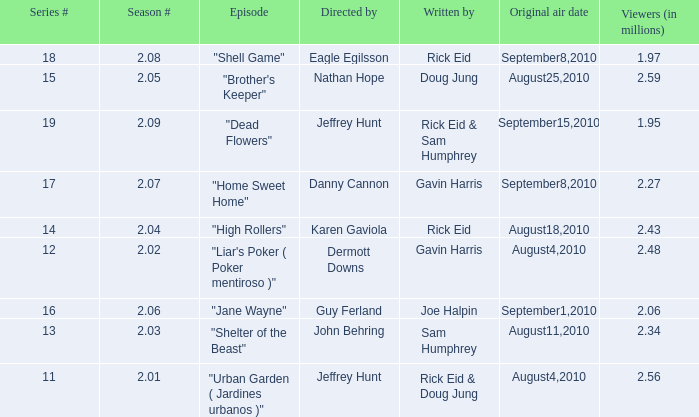If the season number is 2.08, who was the episode written by? Rick Eid. 